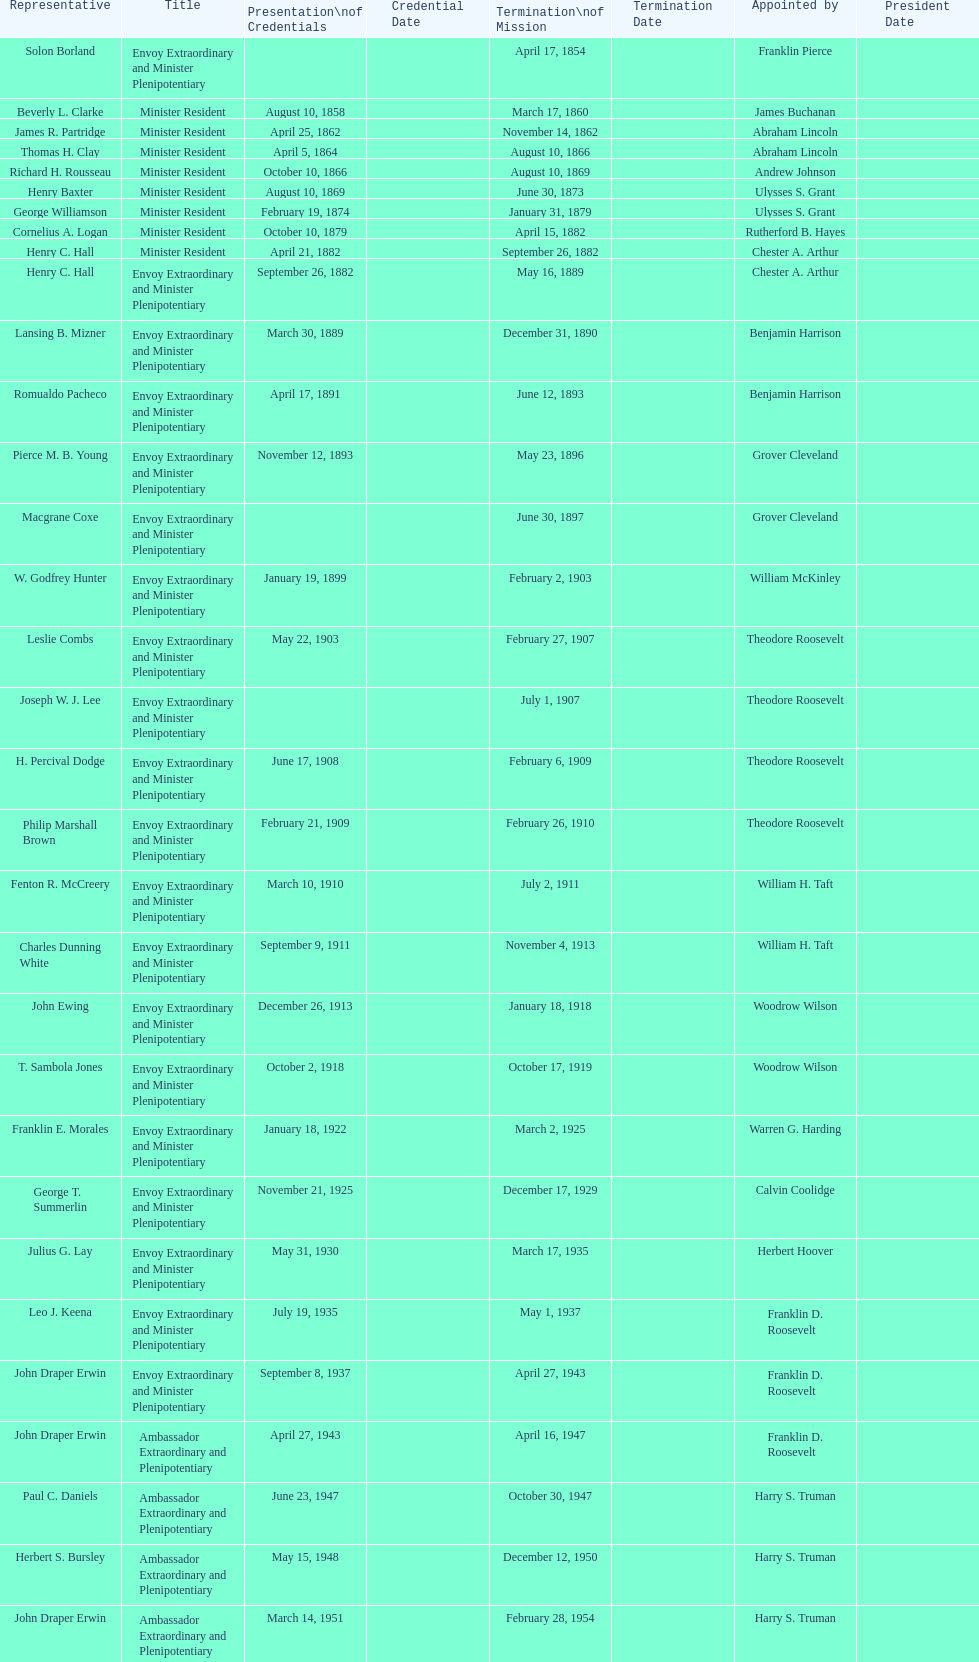Who became the ambassador after the completion of hewson ryan's mission? Phillip V. Sanchez. 